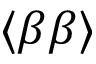Convert formula to latex. <formula><loc_0><loc_0><loc_500><loc_500>\langle \beta \beta \rangle</formula> 